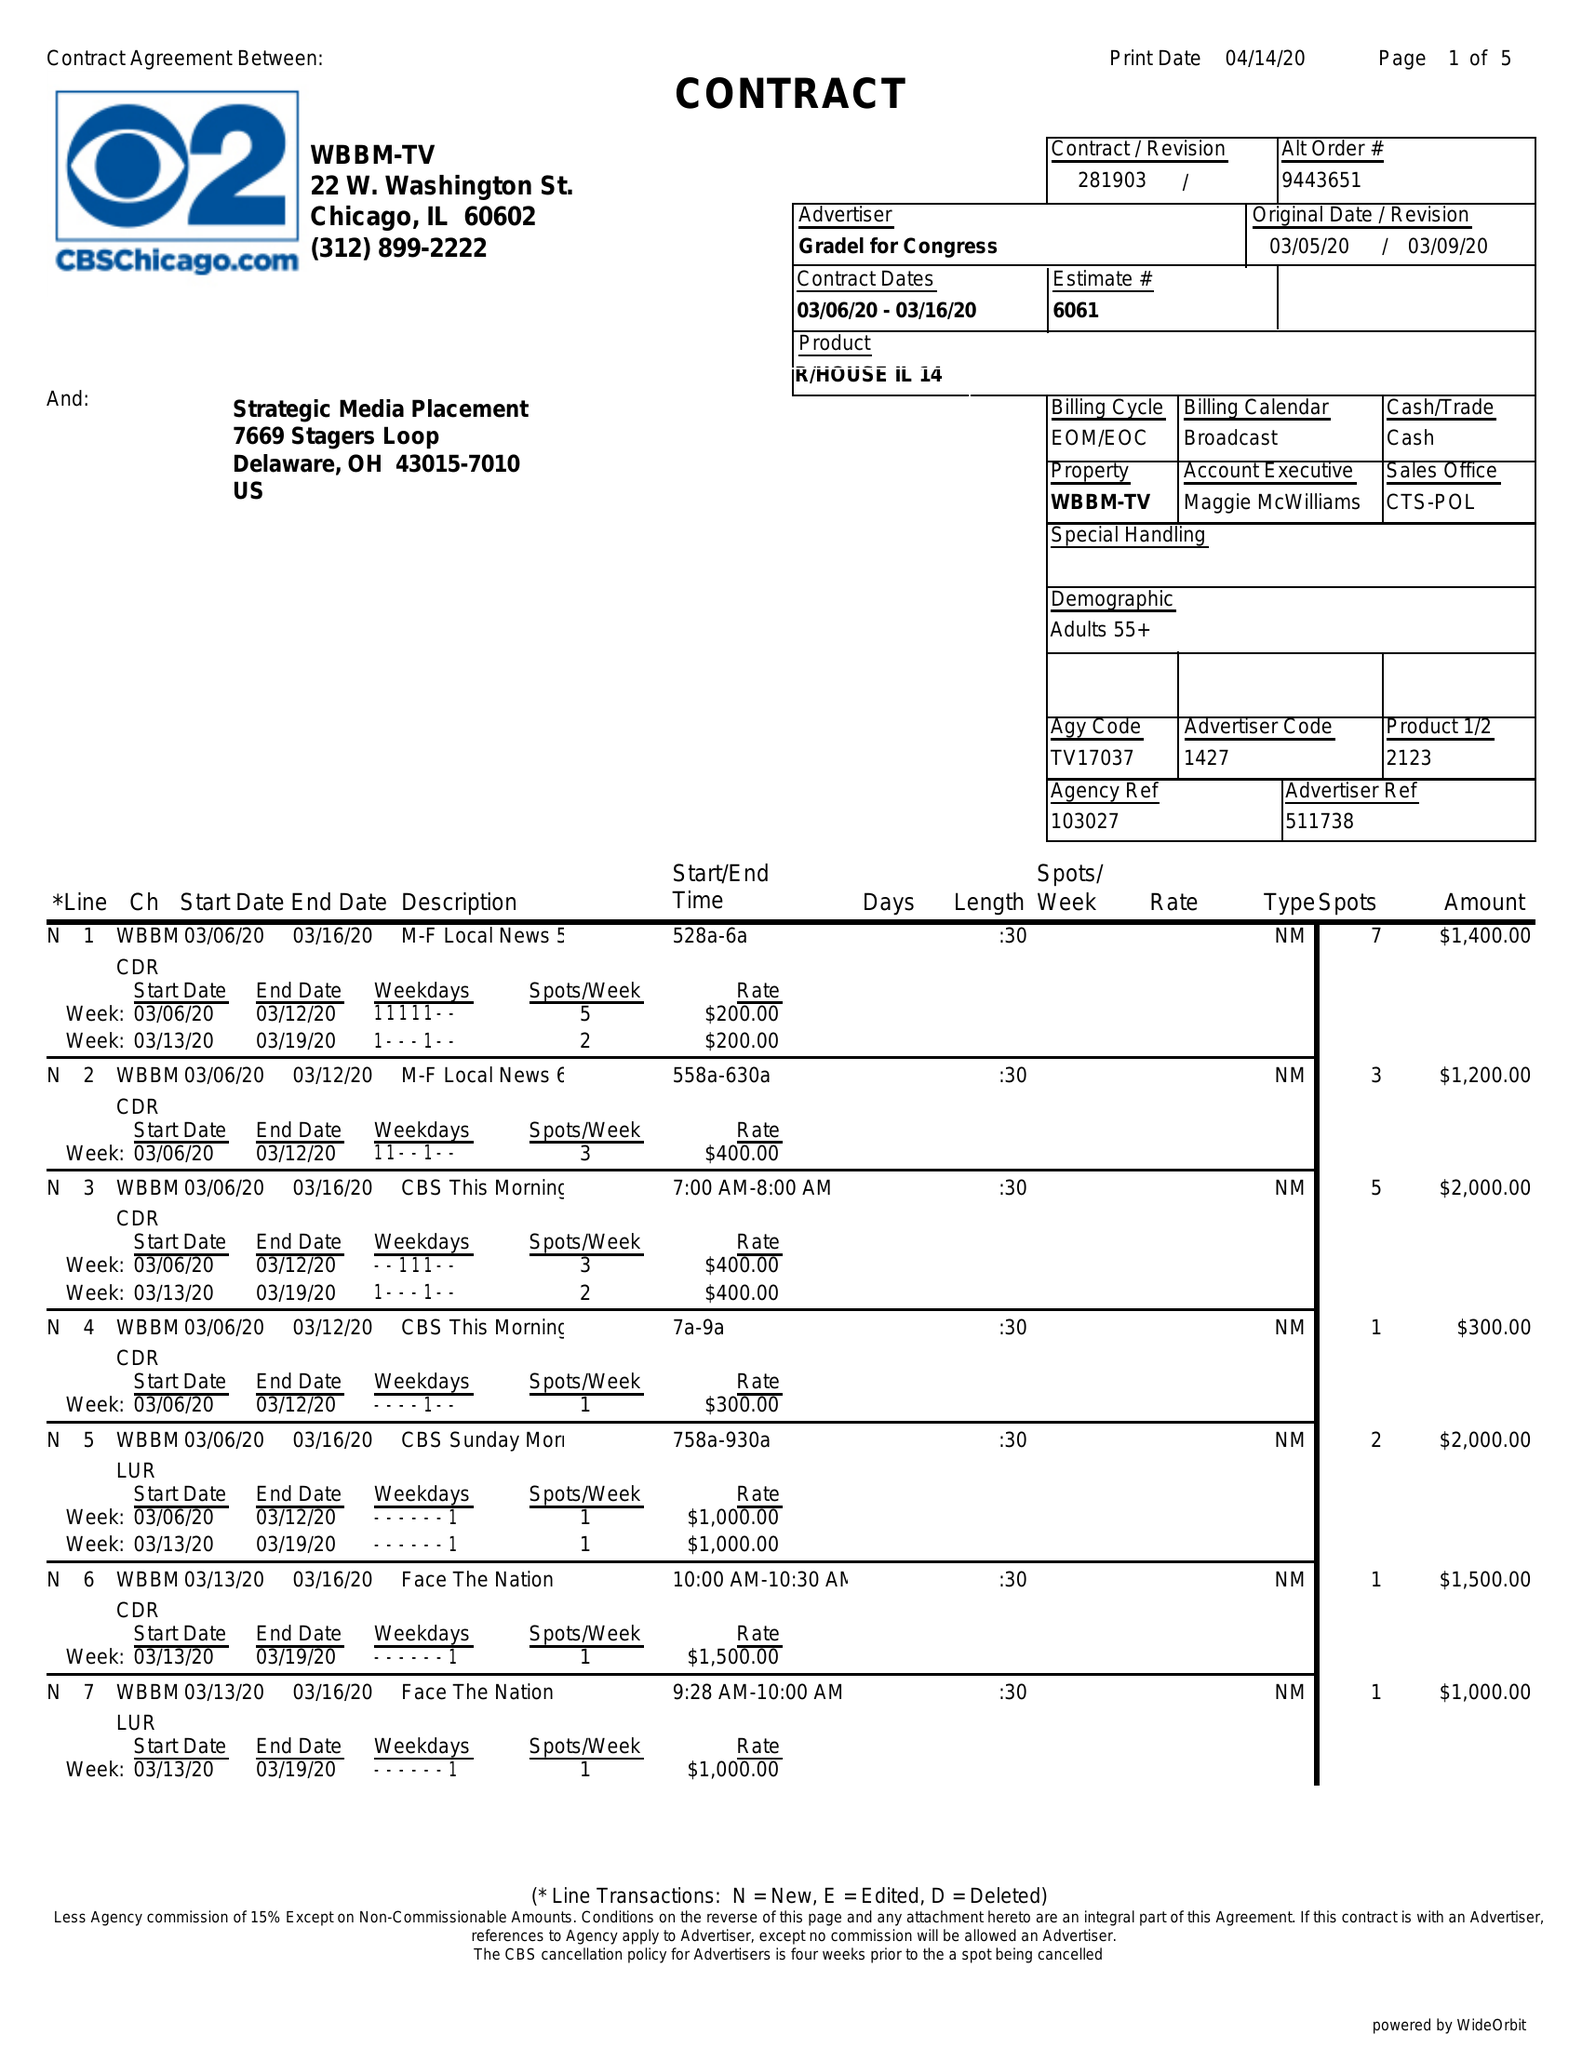What is the value for the flight_to?
Answer the question using a single word or phrase. 03/16/20 